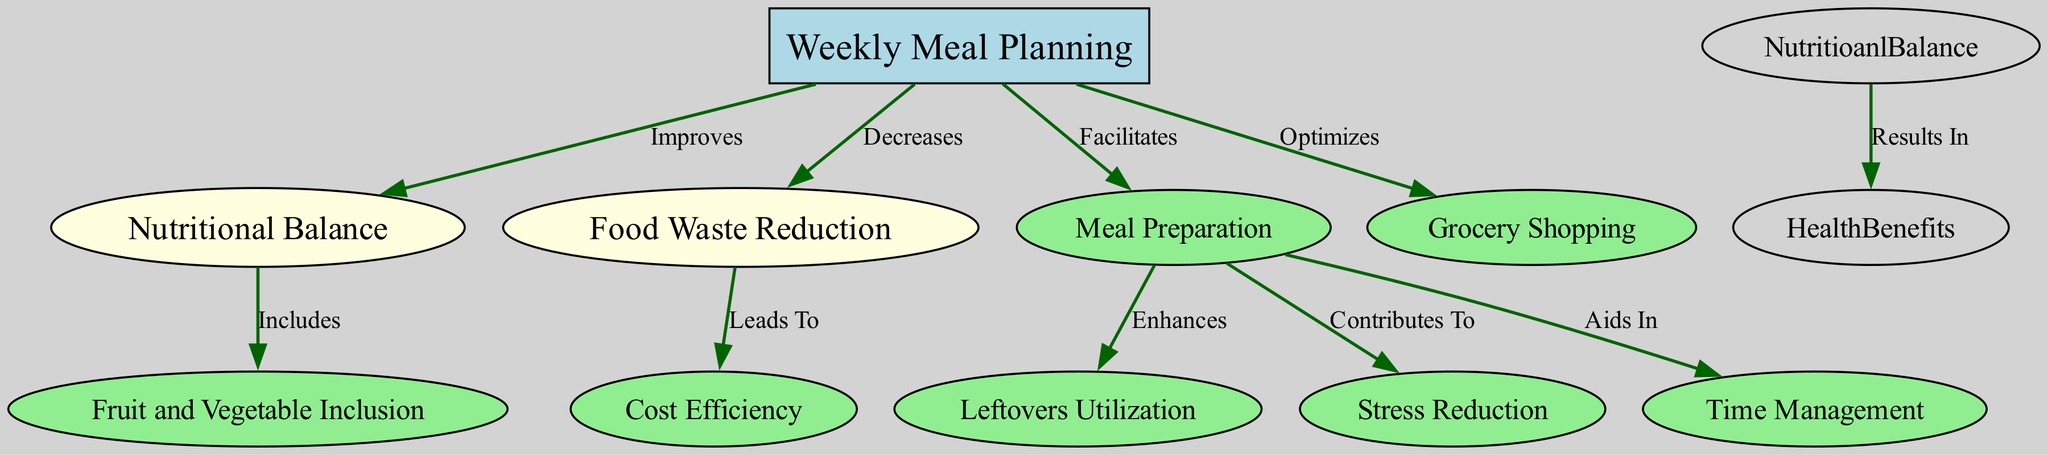What is the main focus of the diagram? The diagram primarily centers around "Weekly Meal Planning" as indicated by its prominent position and the fact that it is the initial node. This node is visually represented as a box and connects to several other nodes, demonstrating its central role.
Answer: Weekly Meal Planning How many nodes are in the diagram? By counting the individual nodes listed in the data, we find a total of 10 nodes representing various aspects related to meal planning and nutrition.
Answer: 10 What does "Weekly Meal Planning" improve? The diagram specifically shows that "Weekly Meal Planning" improves "Nutritional Balance," as indicated by the directed edge labeled "Improves" leading from one node to the other.
Answer: Nutritional Balance Which node does "Meal Preparation" lead to that enhances another aspect? The diagram shows that "Meal Preparation" enhances "Leftovers Utilization," as indicated by the edge labeled "Enhances" connecting them.
Answer: Leftovers Utilization What are the two main outcomes of "Food Waste Reduction"? Based on the diagram, "Food Waste Reduction" leads to "Cost Efficiency" while also being influenced by "Weekly Meal Planning," demonstrating it has both a direct effect and an interconnection with other aspects.
Answer: Cost Efficiency How does "Meal Preparation" affect daily routines? The diagram illustrates that "Meal Preparation" aids in "Time Management," representing how effective meal preparation can streamline daily activities.
Answer: Time Management Which element contributes to reducing stress? "Meal Preparation" contributes to "Stress Reduction," as depicted in the diagram, linking meal prep to lower stress levels related to meal planning and cooking.
Answer: Stress Reduction What is included in the "Nutritional Balance"? The diagram indicates that "Nutritional Balance" specifically includes "Fruit and Vegetable Inclusion" as shown by the direct connection between these two nodes.
Answer: Fruit and Vegetable Inclusion What is the relationship between "Food Waste Reduction" and "Cost Efficiency"? The relationship shown in the diagram indicates that "Food Waste Reduction" leads to "Cost Efficiency," highlighting a beneficial outcome of minimizing waste.
Answer: Leads To 